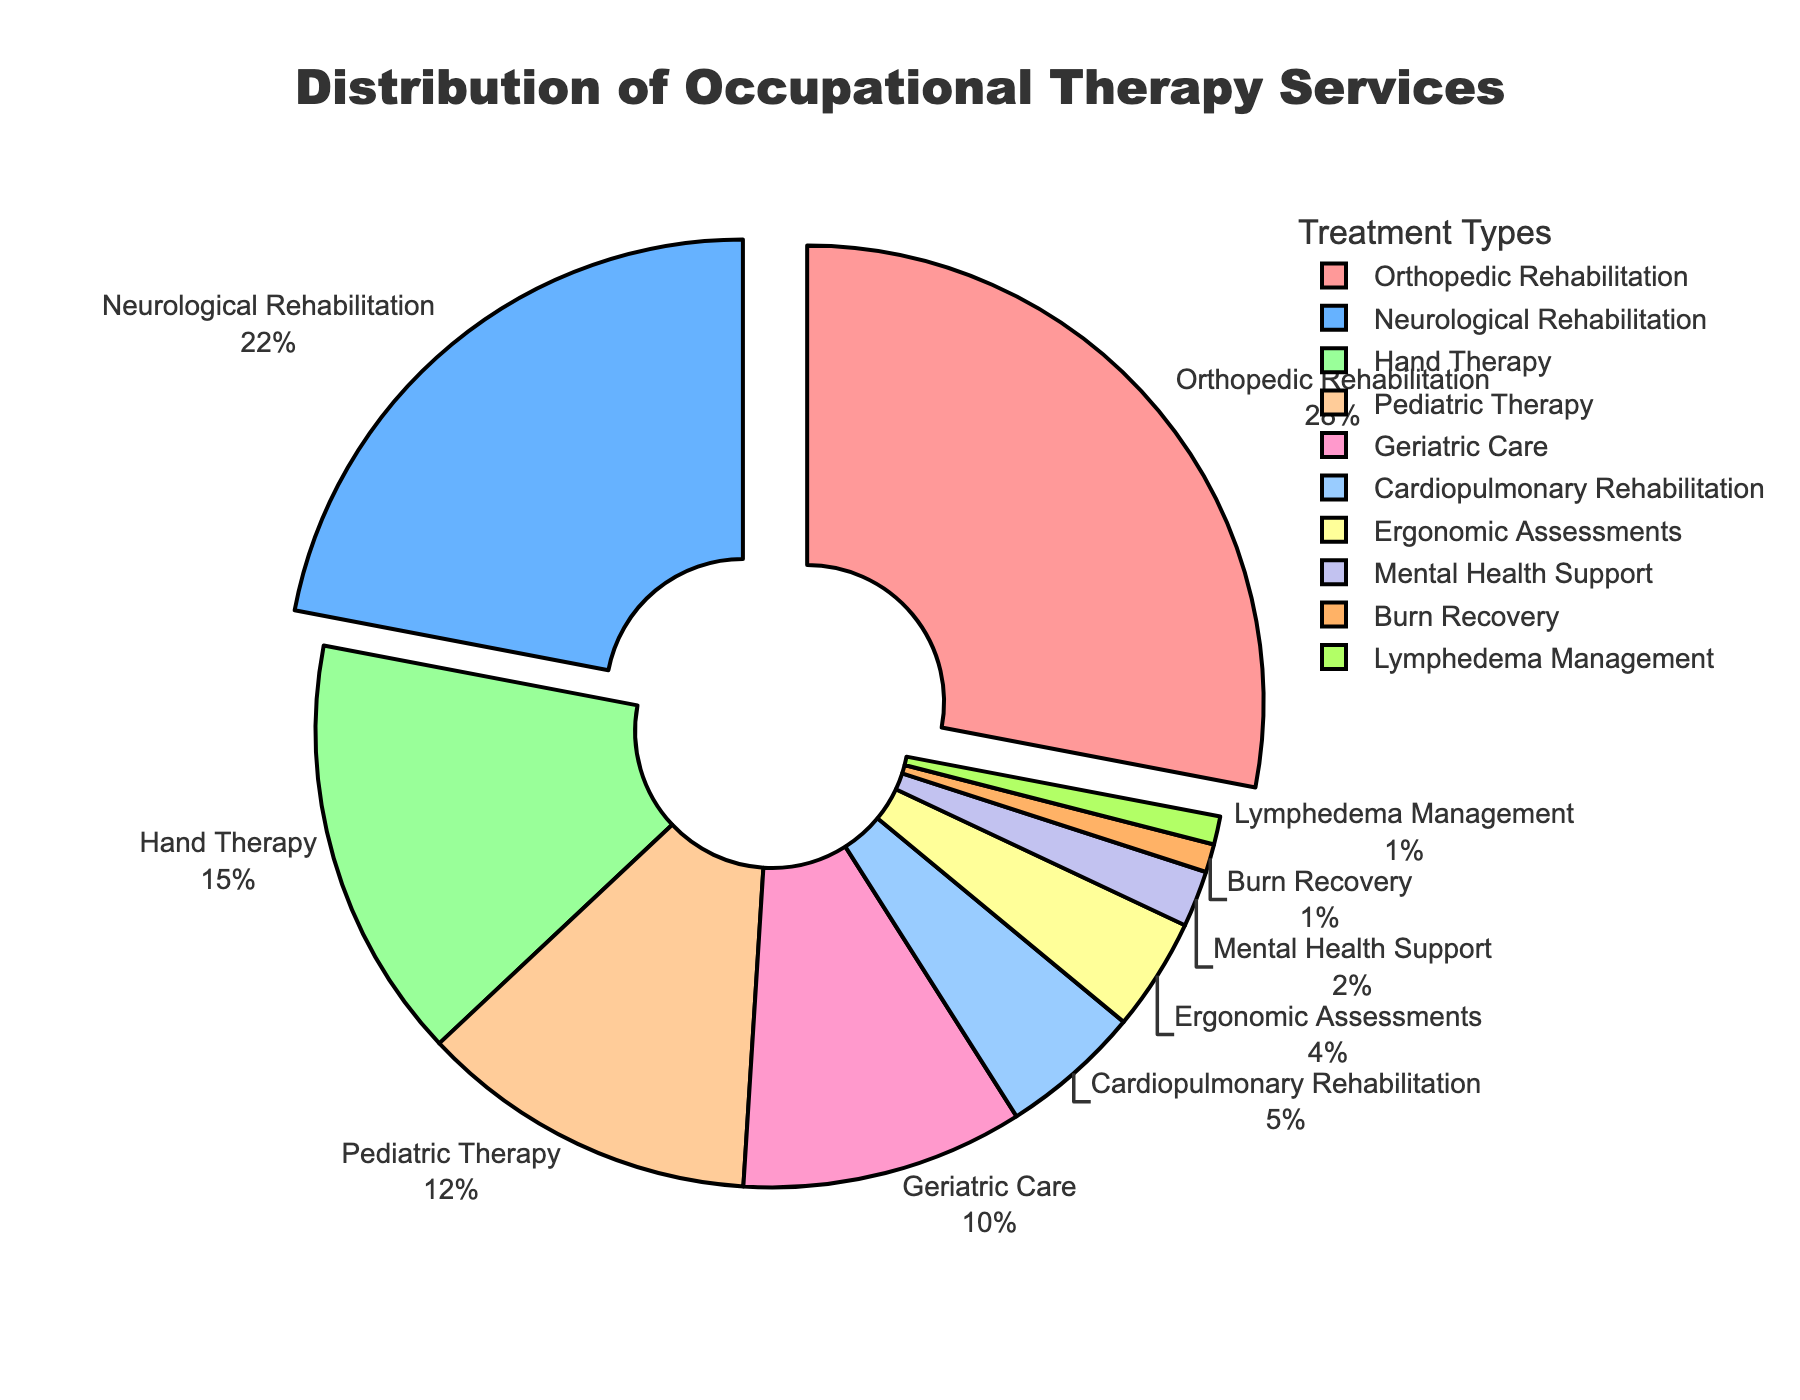Which treatment type has the highest percentage? The treatment type with the highest percentage is identified by finding the largest slice in the pie chart. Orthopedic Rehabilitation has the largest slice.
Answer: Orthopedic Rehabilitation What is the combined percentage of Neurological Rehabilitation and Hand Therapy? To find the combined percentage, add the individual percentages of Neurological Rehabilitation and Hand Therapy. Neurological Rehabilitation is 22% and Hand Therapy is 15%, so 22 + 15 = 37%.
Answer: 37% Which treatment type occupies the smallest portion of the pie chart? The smallest portion of the pie chart is indicated by the smallest slice, which corresponds to the treatment type with the lowest percentage. Lymphedema Management and Burn Recovery both have the smallest slice.
Answer: Lymphedema Management and Burn Recovery How many treatment types collectively make up at least 50% of the total services? To determine the number of treatment types that together make up at least 50%, start from the largest and add the percentages until reaching or exceeding 50%. Orthopedic Rehabilitation (28%) + Neurological Rehabilitation (22%) = 50%. So, two treatment types.
Answer: 2 Is Pediatric Therapy or Geriatric Care more prevalent? Compare the slices representing Pediatric Therapy and Geriatric Care. Pediatric Therapy has 12% and Geriatric Care has 10%. Pediatric Therapy has a larger percentage.
Answer: Pediatric Therapy What is the percentage difference between Ergonomic Assessments and Cardiopulmonary Rehabilitation? To find the difference, subtract the smaller percentage from the larger percentage. Cardiopulmonary Rehabilitation is 5% and Ergonomic Assessments is 4%, so 5 - 4 = 1%.
Answer: 1% Which slices are pulled out from the pie chart? Slices that are pulled out are typically highlighted for emphasis and usually occupied by the largest percentages. Orthopedic Rehabilitation and Neurological Rehabilitation are pulled out, as they have percentages over 20%.
Answer: Orthopedic Rehabilitation and Neurological Rehabilitation If you combine all treatment types with less than 5% each, what would that percentage be? Add the percentages of treatment types that have less than 5%. These include Cardiopulmonary Rehabilitation (5%), Ergonomic Assessments (4%), Mental Health Support (2%), Burn Recovery (1%), and Lymphedema Management (1%). Sum them: 5 + 4 + 2 + 1 + 1 = 13%.
Answer: 13% What is the percentage share of Pediatric Therapy relative to Orthopedic Rehabilitation? To find the relative share, divide the percentage of Pediatric Therapy by the percentage of Orthopedic Rehabilitation and multiply by 100 to get the percentage. (12 / 28) * 100 ≈ 42.86%.
Answer: ≈ 42.86% 